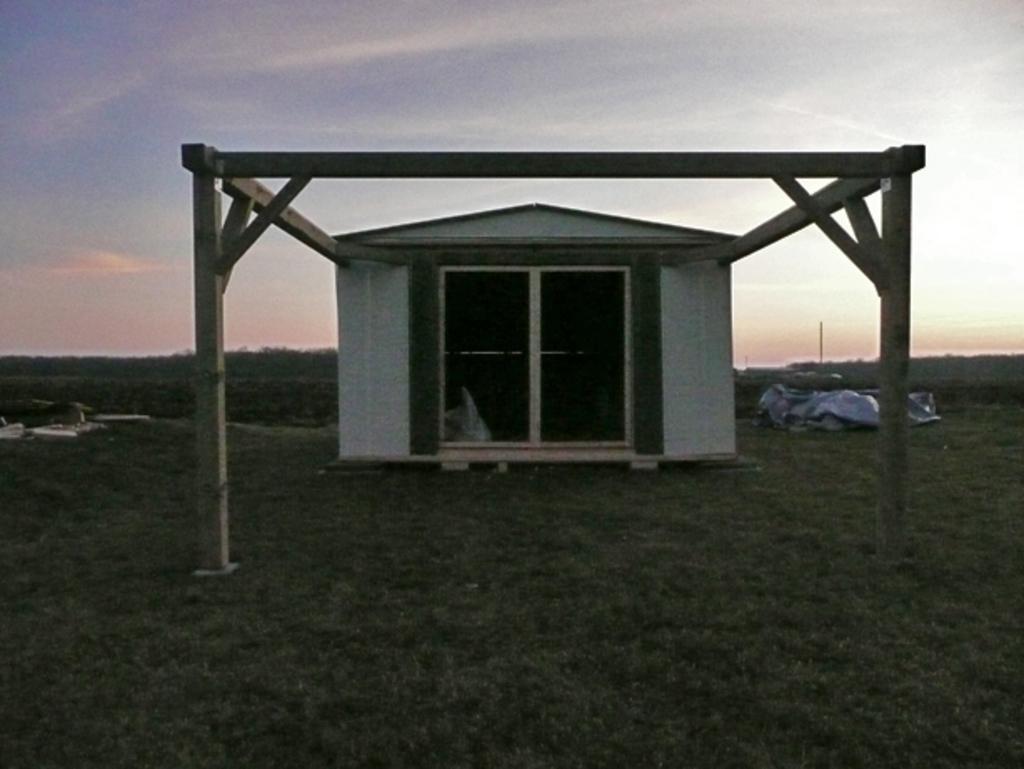Describe this image in one or two sentences. In this image I can see the ground, some grass on the ground, few wooden poles and a shed which is white and black in color. I can see few other objects on the ground and the sky in the background. 